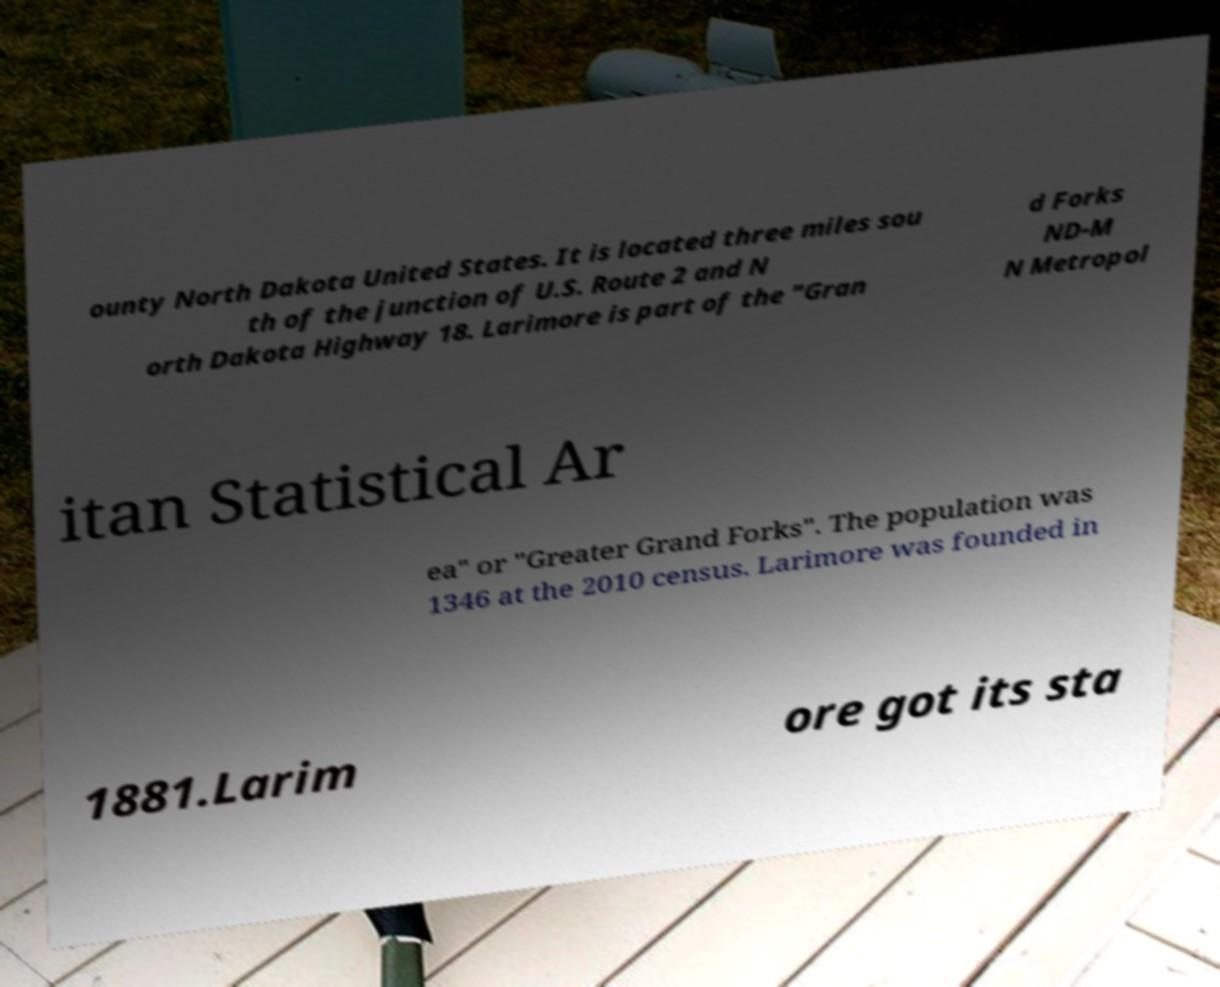What messages or text are displayed in this image? I need them in a readable, typed format. ounty North Dakota United States. It is located three miles sou th of the junction of U.S. Route 2 and N orth Dakota Highway 18. Larimore is part of the "Gran d Forks ND-M N Metropol itan Statistical Ar ea" or "Greater Grand Forks". The population was 1346 at the 2010 census. Larimore was founded in 1881.Larim ore got its sta 